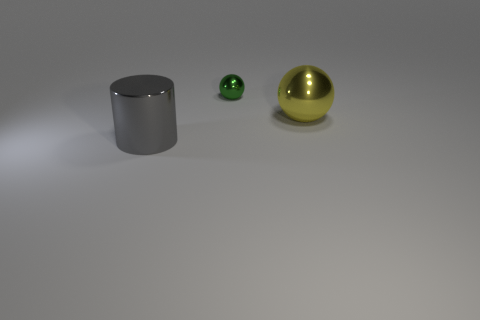Subtract 1 balls. How many balls are left? 1 Add 1 small purple matte blocks. How many objects exist? 4 Subtract all yellow balls. How many balls are left? 1 Subtract all balls. How many objects are left? 1 Subtract all red spheres. Subtract all yellow cubes. How many spheres are left? 2 Subtract all red balls. How many brown cylinders are left? 0 Subtract all metallic spheres. Subtract all large gray metallic objects. How many objects are left? 0 Add 2 large metal spheres. How many large metal spheres are left? 3 Add 3 big red shiny objects. How many big red shiny objects exist? 3 Subtract 0 cyan cylinders. How many objects are left? 3 